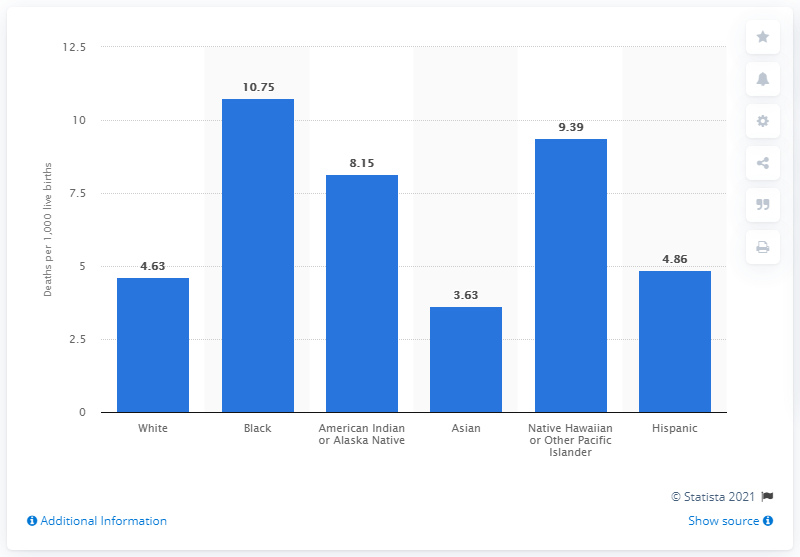Identify some key points in this picture. In 2018, 4.86 Hispanic infants died for every 1,000 live births. 